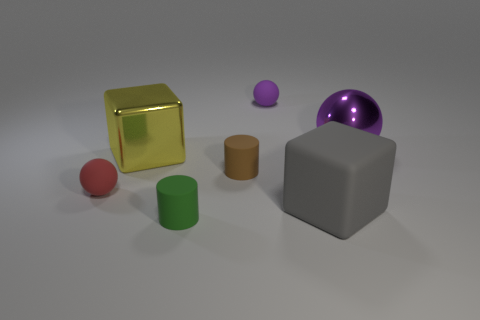There is a cylinder that is behind the rubber cube; what is its material?
Provide a short and direct response. Rubber. What is the size of the thing that is the same color as the big ball?
Ensure brevity in your answer.  Small. Is there a red object that has the same size as the brown matte cylinder?
Keep it short and to the point. Yes. There is a small purple object; is it the same shape as the large metallic object to the right of the large gray block?
Make the answer very short. Yes. There is a cylinder behind the green cylinder; is its size the same as the purple rubber object that is to the right of the brown cylinder?
Provide a short and direct response. Yes. What number of other objects are there of the same shape as the brown rubber thing?
Your answer should be very brief. 1. What is the material of the purple ball that is to the right of the purple object that is behind the purple metallic ball?
Offer a very short reply. Metal. How many matte things are either cylinders or big things?
Provide a short and direct response. 3. Are there any other things that have the same material as the small red object?
Provide a succinct answer. Yes. There is a purple object to the left of the large gray matte cube; are there any tiny things that are left of it?
Your response must be concise. Yes. 